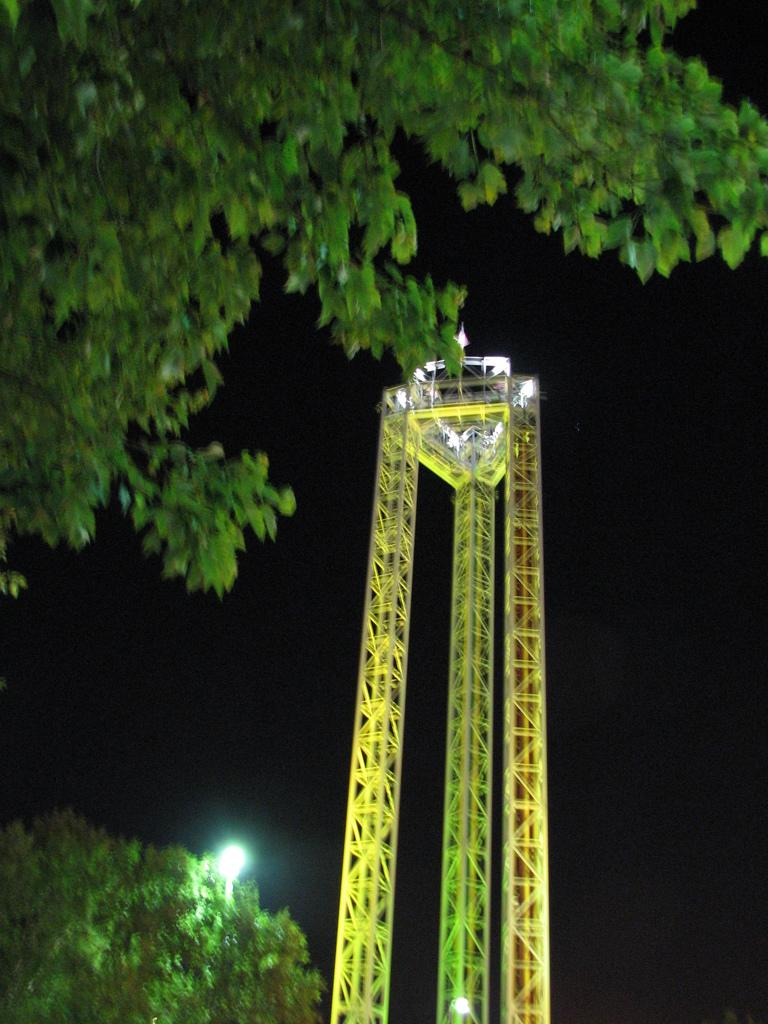What is the main subject of the image? There is a crane in the image. What can be seen on the left side of the image? There are trees on the left side of the image. How many geese are flying over the crane in the image? There are no geese present in the image; it only features a crane and trees. What type of shirt is the crane wearing in the image? Cranes do not wear clothing, so there is no shirt present in the image. 